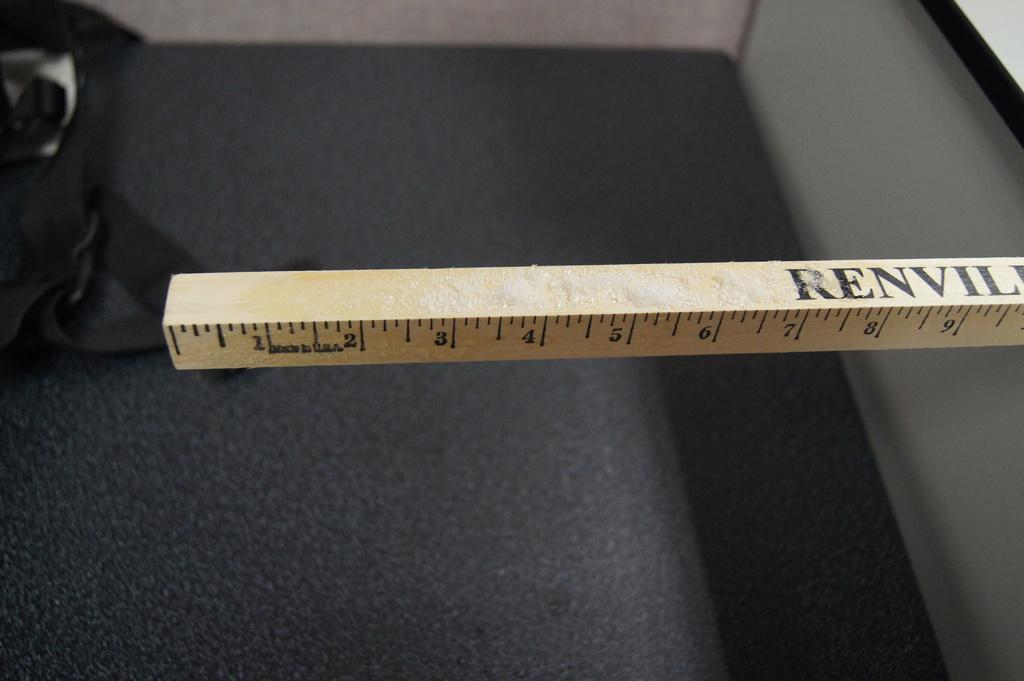<image>
Provide a brief description of the given image. Long brown ruler that says "RENVIL" in black on top. 